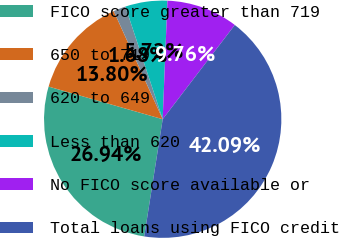<chart> <loc_0><loc_0><loc_500><loc_500><pie_chart><fcel>FICO score greater than 719<fcel>650 to 719<fcel>620 to 649<fcel>Less than 620<fcel>No FICO score available or<fcel>Total loans using FICO credit<nl><fcel>26.94%<fcel>13.8%<fcel>1.68%<fcel>5.72%<fcel>9.76%<fcel>42.09%<nl></chart> 